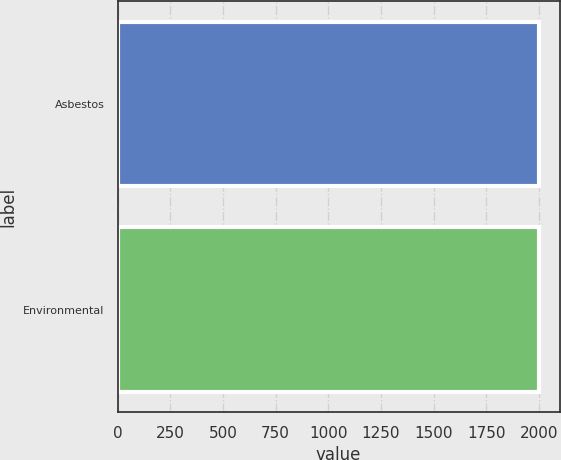<chart> <loc_0><loc_0><loc_500><loc_500><bar_chart><fcel>Asbestos<fcel>Environmental<nl><fcel>1998<fcel>1998.1<nl></chart> 